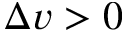<formula> <loc_0><loc_0><loc_500><loc_500>\Delta v > 0</formula> 